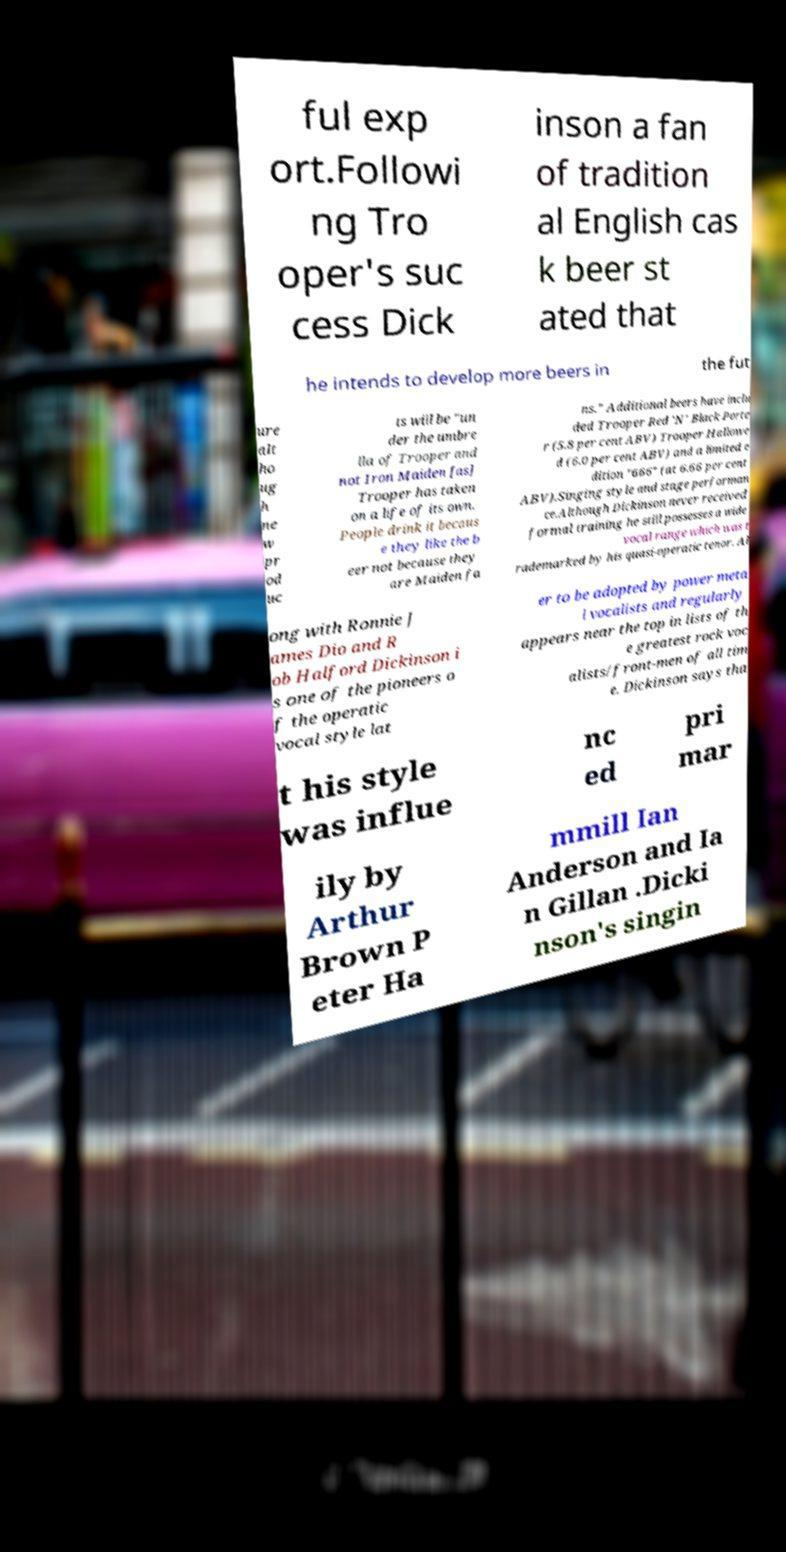There's text embedded in this image that I need extracted. Can you transcribe it verbatim? ful exp ort.Followi ng Tro oper's suc cess Dick inson a fan of tradition al English cas k beer st ated that he intends to develop more beers in the fut ure alt ho ug h ne w pr od uc ts will be "un der the umbre lla of Trooper and not Iron Maiden [as] Trooper has taken on a life of its own. People drink it becaus e they like the b eer not because they are Maiden fa ns." Additional beers have inclu ded Trooper Red 'N' Black Porte r (5.8 per cent ABV) Trooper Hallowe d (6.0 per cent ABV) and a limited e dition "666" (at 6.66 per cent ABV).Singing style and stage performan ce.Although Dickinson never received formal training he still possesses a wide vocal range which was t rademarked by his quasi-operatic tenor. Al ong with Ronnie J ames Dio and R ob Halford Dickinson i s one of the pioneers o f the operatic vocal style lat er to be adopted by power meta l vocalists and regularly appears near the top in lists of th e greatest rock voc alists/front-men of all tim e. Dickinson says tha t his style was influe nc ed pri mar ily by Arthur Brown P eter Ha mmill Ian Anderson and Ia n Gillan .Dicki nson's singin 